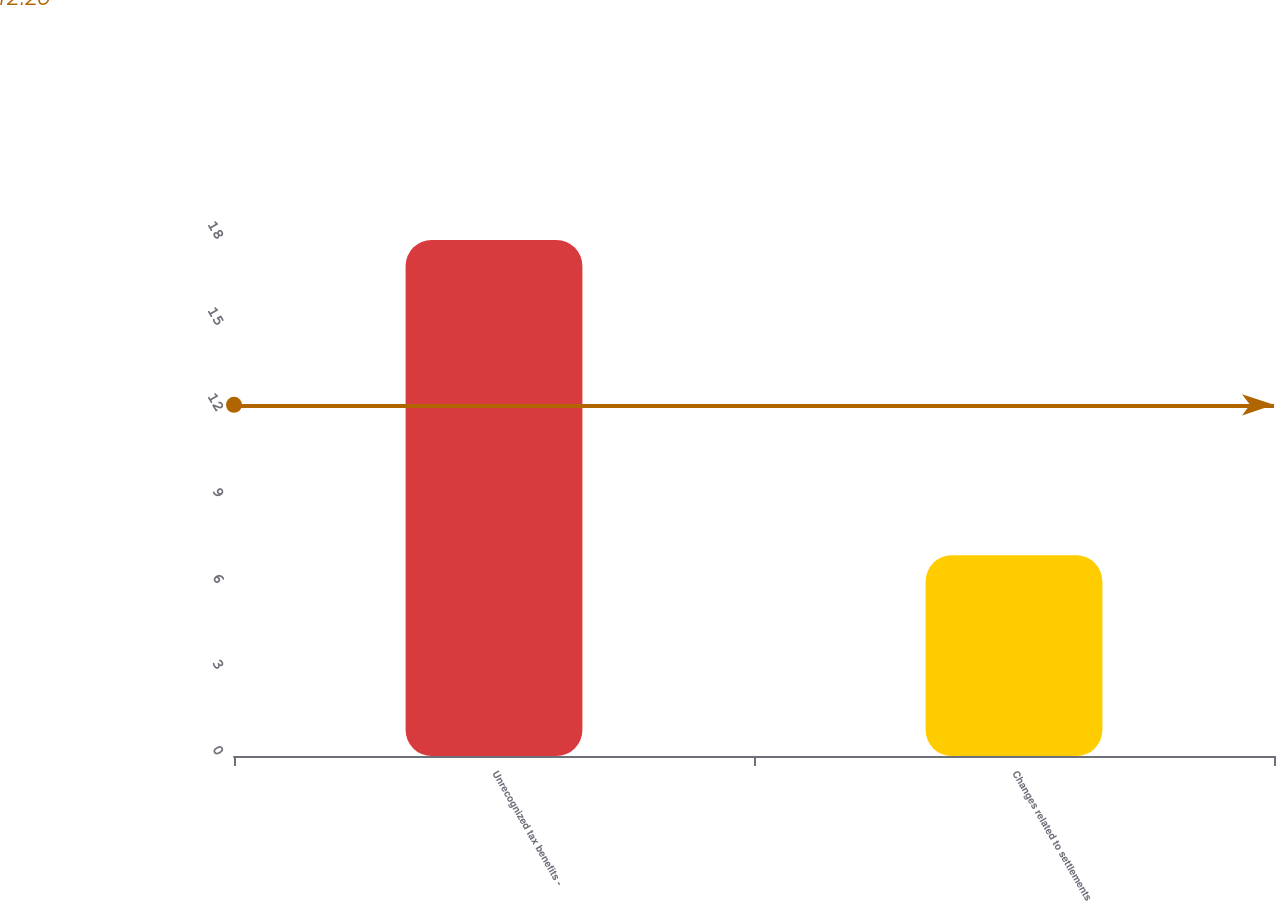Convert chart to OTSL. <chart><loc_0><loc_0><loc_500><loc_500><bar_chart><fcel>Unrecognized tax benefits -<fcel>Changes related to settlements<nl><fcel>18<fcel>7<nl></chart> 